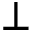<formula> <loc_0><loc_0><loc_500><loc_500>\bot</formula> 